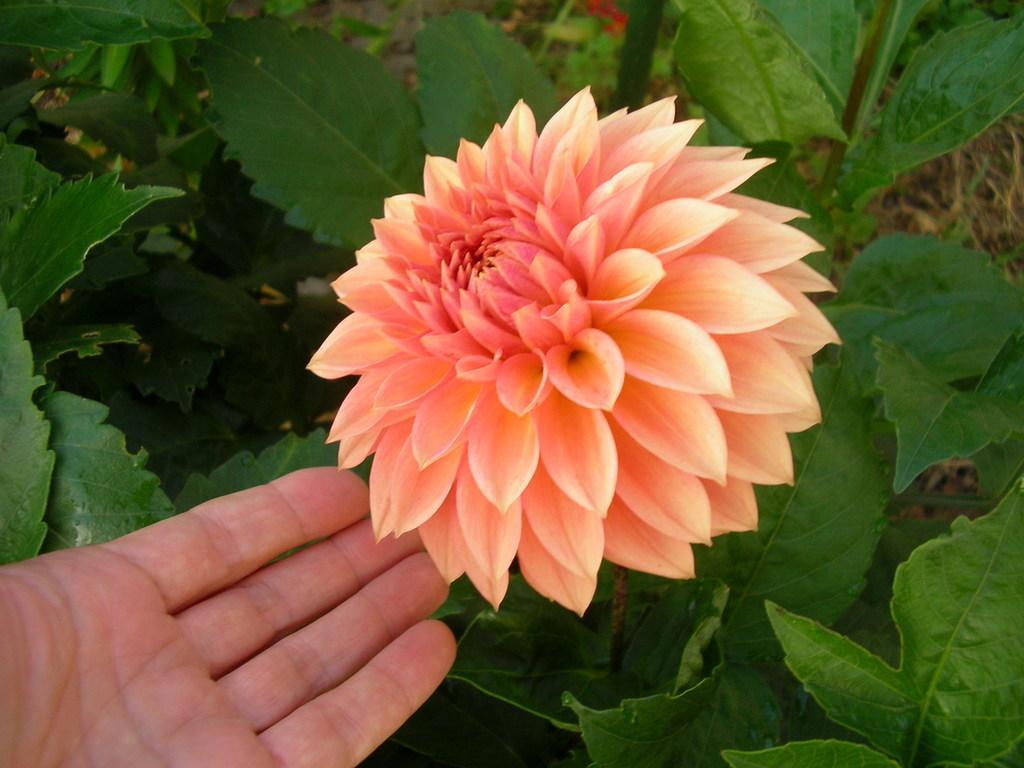How would you summarize this image in a sentence or two? In this image we can see a flower to the plant and a human hand. 